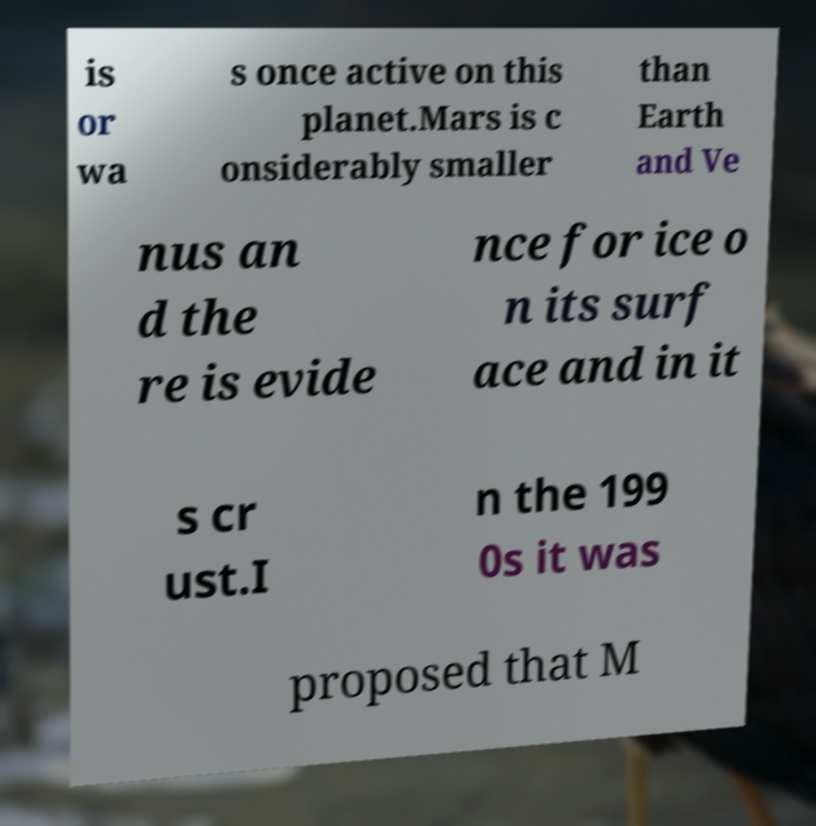I need the written content from this picture converted into text. Can you do that? is or wa s once active on this planet.Mars is c onsiderably smaller than Earth and Ve nus an d the re is evide nce for ice o n its surf ace and in it s cr ust.I n the 199 0s it was proposed that M 